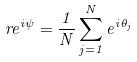<formula> <loc_0><loc_0><loc_500><loc_500>r e ^ { i \psi } = \frac { 1 } { N } \sum _ { j = 1 } ^ { N } e ^ { i \theta _ { j } }</formula> 